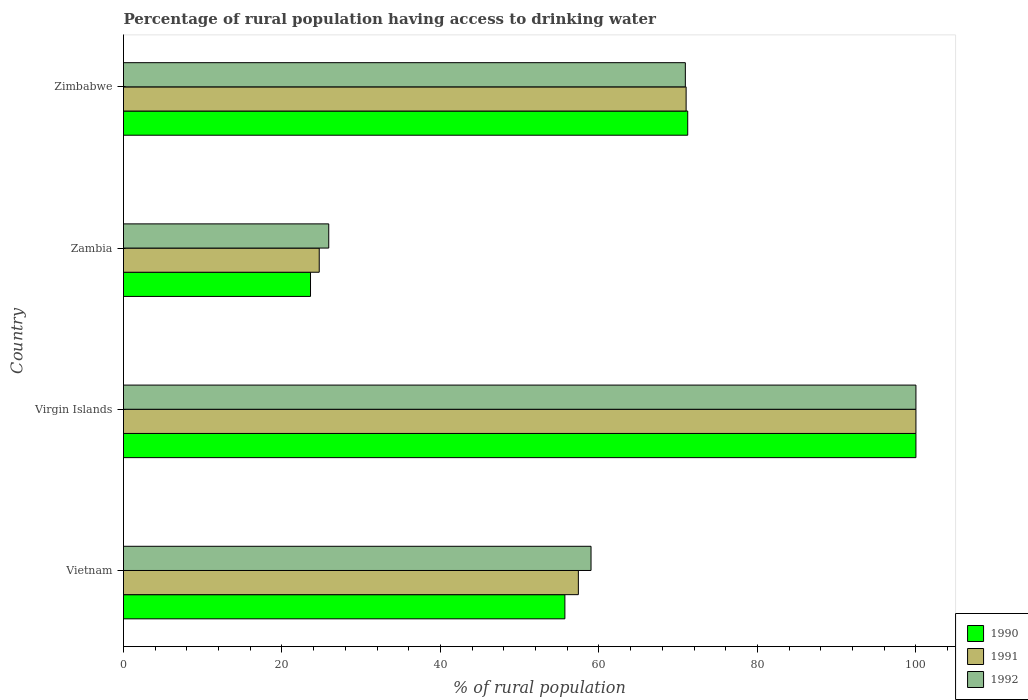How many bars are there on the 3rd tick from the top?
Your answer should be very brief. 3. How many bars are there on the 4th tick from the bottom?
Give a very brief answer. 3. What is the label of the 4th group of bars from the top?
Offer a terse response. Vietnam. In how many cases, is the number of bars for a given country not equal to the number of legend labels?
Make the answer very short. 0. What is the percentage of rural population having access to drinking water in 1992 in Zimbabwe?
Offer a very short reply. 70.9. Across all countries, what is the minimum percentage of rural population having access to drinking water in 1992?
Your response must be concise. 25.9. In which country was the percentage of rural population having access to drinking water in 1990 maximum?
Your answer should be very brief. Virgin Islands. In which country was the percentage of rural population having access to drinking water in 1991 minimum?
Keep it short and to the point. Zambia. What is the total percentage of rural population having access to drinking water in 1991 in the graph?
Give a very brief answer. 253.1. What is the difference between the percentage of rural population having access to drinking water in 1990 in Vietnam and that in Virgin Islands?
Keep it short and to the point. -44.3. What is the average percentage of rural population having access to drinking water in 1991 per country?
Keep it short and to the point. 63.27. What is the difference between the percentage of rural population having access to drinking water in 1992 and percentage of rural population having access to drinking water in 1991 in Zimbabwe?
Make the answer very short. -0.1. What is the ratio of the percentage of rural population having access to drinking water in 1991 in Zambia to that in Zimbabwe?
Offer a very short reply. 0.35. What is the difference between the highest and the second highest percentage of rural population having access to drinking water in 1992?
Your response must be concise. 29.1. What is the difference between the highest and the lowest percentage of rural population having access to drinking water in 1992?
Give a very brief answer. 74.1. In how many countries, is the percentage of rural population having access to drinking water in 1991 greater than the average percentage of rural population having access to drinking water in 1991 taken over all countries?
Your answer should be very brief. 2. What does the 3rd bar from the top in Zambia represents?
Your response must be concise. 1990. How many countries are there in the graph?
Ensure brevity in your answer.  4. Are the values on the major ticks of X-axis written in scientific E-notation?
Your answer should be very brief. No. Where does the legend appear in the graph?
Your response must be concise. Bottom right. How many legend labels are there?
Provide a short and direct response. 3. What is the title of the graph?
Your answer should be very brief. Percentage of rural population having access to drinking water. What is the label or title of the X-axis?
Your answer should be very brief. % of rural population. What is the % of rural population in 1990 in Vietnam?
Give a very brief answer. 55.7. What is the % of rural population in 1991 in Vietnam?
Your response must be concise. 57.4. What is the % of rural population of 1990 in Virgin Islands?
Ensure brevity in your answer.  100. What is the % of rural population in 1990 in Zambia?
Make the answer very short. 23.6. What is the % of rural population in 1991 in Zambia?
Offer a very short reply. 24.7. What is the % of rural population of 1992 in Zambia?
Ensure brevity in your answer.  25.9. What is the % of rural population in 1990 in Zimbabwe?
Provide a succinct answer. 71.2. What is the % of rural population in 1992 in Zimbabwe?
Ensure brevity in your answer.  70.9. Across all countries, what is the maximum % of rural population of 1991?
Your answer should be compact. 100. Across all countries, what is the maximum % of rural population in 1992?
Make the answer very short. 100. Across all countries, what is the minimum % of rural population of 1990?
Keep it short and to the point. 23.6. Across all countries, what is the minimum % of rural population in 1991?
Provide a short and direct response. 24.7. Across all countries, what is the minimum % of rural population in 1992?
Keep it short and to the point. 25.9. What is the total % of rural population of 1990 in the graph?
Provide a succinct answer. 250.5. What is the total % of rural population of 1991 in the graph?
Offer a very short reply. 253.1. What is the total % of rural population in 1992 in the graph?
Provide a short and direct response. 255.8. What is the difference between the % of rural population in 1990 in Vietnam and that in Virgin Islands?
Provide a short and direct response. -44.3. What is the difference between the % of rural population in 1991 in Vietnam and that in Virgin Islands?
Offer a very short reply. -42.6. What is the difference between the % of rural population of 1992 in Vietnam and that in Virgin Islands?
Your answer should be very brief. -41. What is the difference between the % of rural population of 1990 in Vietnam and that in Zambia?
Your response must be concise. 32.1. What is the difference between the % of rural population of 1991 in Vietnam and that in Zambia?
Your answer should be very brief. 32.7. What is the difference between the % of rural population in 1992 in Vietnam and that in Zambia?
Offer a terse response. 33.1. What is the difference between the % of rural population of 1990 in Vietnam and that in Zimbabwe?
Your response must be concise. -15.5. What is the difference between the % of rural population in 1991 in Vietnam and that in Zimbabwe?
Make the answer very short. -13.6. What is the difference between the % of rural population of 1990 in Virgin Islands and that in Zambia?
Offer a very short reply. 76.4. What is the difference between the % of rural population of 1991 in Virgin Islands and that in Zambia?
Provide a short and direct response. 75.3. What is the difference between the % of rural population in 1992 in Virgin Islands and that in Zambia?
Keep it short and to the point. 74.1. What is the difference between the % of rural population of 1990 in Virgin Islands and that in Zimbabwe?
Ensure brevity in your answer.  28.8. What is the difference between the % of rural population in 1992 in Virgin Islands and that in Zimbabwe?
Your answer should be compact. 29.1. What is the difference between the % of rural population in 1990 in Zambia and that in Zimbabwe?
Your response must be concise. -47.6. What is the difference between the % of rural population in 1991 in Zambia and that in Zimbabwe?
Offer a very short reply. -46.3. What is the difference between the % of rural population of 1992 in Zambia and that in Zimbabwe?
Your answer should be very brief. -45. What is the difference between the % of rural population in 1990 in Vietnam and the % of rural population in 1991 in Virgin Islands?
Provide a short and direct response. -44.3. What is the difference between the % of rural population in 1990 in Vietnam and the % of rural population in 1992 in Virgin Islands?
Give a very brief answer. -44.3. What is the difference between the % of rural population in 1991 in Vietnam and the % of rural population in 1992 in Virgin Islands?
Your response must be concise. -42.6. What is the difference between the % of rural population in 1990 in Vietnam and the % of rural population in 1991 in Zambia?
Provide a succinct answer. 31. What is the difference between the % of rural population in 1990 in Vietnam and the % of rural population in 1992 in Zambia?
Offer a terse response. 29.8. What is the difference between the % of rural population in 1991 in Vietnam and the % of rural population in 1992 in Zambia?
Provide a succinct answer. 31.5. What is the difference between the % of rural population of 1990 in Vietnam and the % of rural population of 1991 in Zimbabwe?
Offer a terse response. -15.3. What is the difference between the % of rural population of 1990 in Vietnam and the % of rural population of 1992 in Zimbabwe?
Provide a short and direct response. -15.2. What is the difference between the % of rural population of 1990 in Virgin Islands and the % of rural population of 1991 in Zambia?
Offer a very short reply. 75.3. What is the difference between the % of rural population in 1990 in Virgin Islands and the % of rural population in 1992 in Zambia?
Offer a terse response. 74.1. What is the difference between the % of rural population in 1991 in Virgin Islands and the % of rural population in 1992 in Zambia?
Ensure brevity in your answer.  74.1. What is the difference between the % of rural population in 1990 in Virgin Islands and the % of rural population in 1992 in Zimbabwe?
Keep it short and to the point. 29.1. What is the difference between the % of rural population in 1991 in Virgin Islands and the % of rural population in 1992 in Zimbabwe?
Your answer should be very brief. 29.1. What is the difference between the % of rural population in 1990 in Zambia and the % of rural population in 1991 in Zimbabwe?
Provide a short and direct response. -47.4. What is the difference between the % of rural population in 1990 in Zambia and the % of rural population in 1992 in Zimbabwe?
Provide a short and direct response. -47.3. What is the difference between the % of rural population in 1991 in Zambia and the % of rural population in 1992 in Zimbabwe?
Keep it short and to the point. -46.2. What is the average % of rural population of 1990 per country?
Offer a very short reply. 62.62. What is the average % of rural population of 1991 per country?
Keep it short and to the point. 63.27. What is the average % of rural population in 1992 per country?
Offer a very short reply. 63.95. What is the difference between the % of rural population of 1990 and % of rural population of 1991 in Vietnam?
Offer a very short reply. -1.7. What is the difference between the % of rural population of 1990 and % of rural population of 1992 in Vietnam?
Provide a succinct answer. -3.3. What is the difference between the % of rural population of 1990 and % of rural population of 1991 in Virgin Islands?
Your answer should be compact. 0. What is the difference between the % of rural population in 1990 and % of rural population in 1991 in Zambia?
Provide a succinct answer. -1.1. What is the difference between the % of rural population of 1991 and % of rural population of 1992 in Zambia?
Offer a terse response. -1.2. What is the difference between the % of rural population of 1990 and % of rural population of 1992 in Zimbabwe?
Give a very brief answer. 0.3. What is the difference between the % of rural population of 1991 and % of rural population of 1992 in Zimbabwe?
Offer a terse response. 0.1. What is the ratio of the % of rural population in 1990 in Vietnam to that in Virgin Islands?
Your answer should be very brief. 0.56. What is the ratio of the % of rural population of 1991 in Vietnam to that in Virgin Islands?
Keep it short and to the point. 0.57. What is the ratio of the % of rural population in 1992 in Vietnam to that in Virgin Islands?
Your answer should be very brief. 0.59. What is the ratio of the % of rural population of 1990 in Vietnam to that in Zambia?
Offer a very short reply. 2.36. What is the ratio of the % of rural population of 1991 in Vietnam to that in Zambia?
Provide a succinct answer. 2.32. What is the ratio of the % of rural population of 1992 in Vietnam to that in Zambia?
Offer a very short reply. 2.28. What is the ratio of the % of rural population of 1990 in Vietnam to that in Zimbabwe?
Offer a very short reply. 0.78. What is the ratio of the % of rural population of 1991 in Vietnam to that in Zimbabwe?
Provide a succinct answer. 0.81. What is the ratio of the % of rural population in 1992 in Vietnam to that in Zimbabwe?
Keep it short and to the point. 0.83. What is the ratio of the % of rural population of 1990 in Virgin Islands to that in Zambia?
Make the answer very short. 4.24. What is the ratio of the % of rural population of 1991 in Virgin Islands to that in Zambia?
Offer a terse response. 4.05. What is the ratio of the % of rural population of 1992 in Virgin Islands to that in Zambia?
Your answer should be compact. 3.86. What is the ratio of the % of rural population in 1990 in Virgin Islands to that in Zimbabwe?
Offer a terse response. 1.4. What is the ratio of the % of rural population of 1991 in Virgin Islands to that in Zimbabwe?
Offer a terse response. 1.41. What is the ratio of the % of rural population of 1992 in Virgin Islands to that in Zimbabwe?
Provide a short and direct response. 1.41. What is the ratio of the % of rural population in 1990 in Zambia to that in Zimbabwe?
Offer a very short reply. 0.33. What is the ratio of the % of rural population in 1991 in Zambia to that in Zimbabwe?
Your answer should be very brief. 0.35. What is the ratio of the % of rural population in 1992 in Zambia to that in Zimbabwe?
Make the answer very short. 0.37. What is the difference between the highest and the second highest % of rural population of 1990?
Your response must be concise. 28.8. What is the difference between the highest and the second highest % of rural population in 1991?
Make the answer very short. 29. What is the difference between the highest and the second highest % of rural population in 1992?
Your answer should be very brief. 29.1. What is the difference between the highest and the lowest % of rural population of 1990?
Your response must be concise. 76.4. What is the difference between the highest and the lowest % of rural population in 1991?
Offer a very short reply. 75.3. What is the difference between the highest and the lowest % of rural population of 1992?
Offer a terse response. 74.1. 